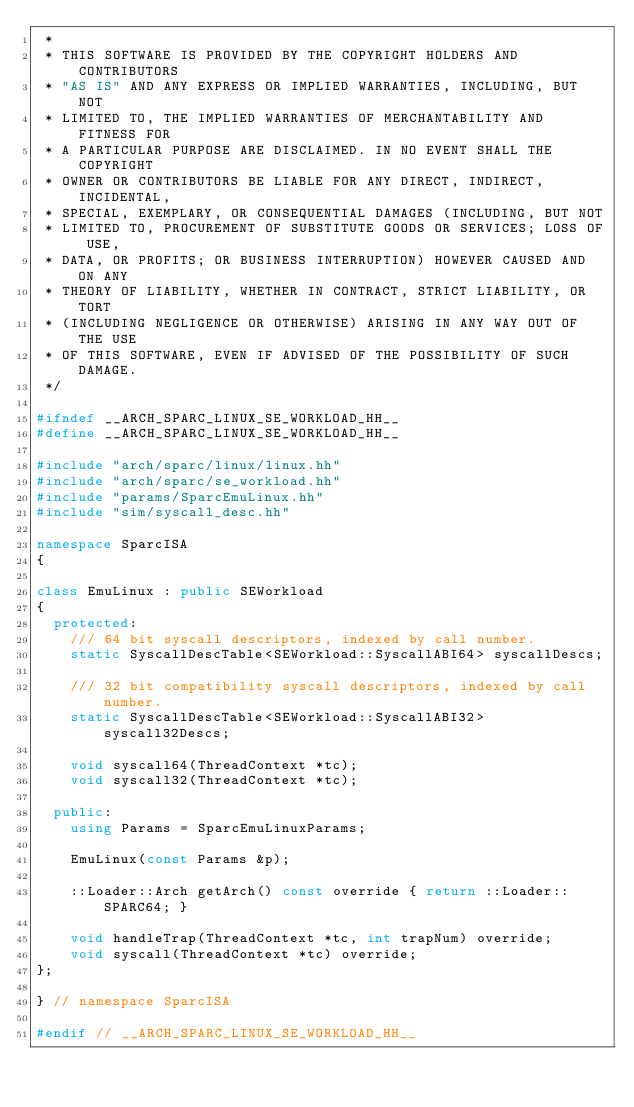<code> <loc_0><loc_0><loc_500><loc_500><_C++_> *
 * THIS SOFTWARE IS PROVIDED BY THE COPYRIGHT HOLDERS AND CONTRIBUTORS
 * "AS IS" AND ANY EXPRESS OR IMPLIED WARRANTIES, INCLUDING, BUT NOT
 * LIMITED TO, THE IMPLIED WARRANTIES OF MERCHANTABILITY AND FITNESS FOR
 * A PARTICULAR PURPOSE ARE DISCLAIMED. IN NO EVENT SHALL THE COPYRIGHT
 * OWNER OR CONTRIBUTORS BE LIABLE FOR ANY DIRECT, INDIRECT, INCIDENTAL,
 * SPECIAL, EXEMPLARY, OR CONSEQUENTIAL DAMAGES (INCLUDING, BUT NOT
 * LIMITED TO, PROCUREMENT OF SUBSTITUTE GOODS OR SERVICES; LOSS OF USE,
 * DATA, OR PROFITS; OR BUSINESS INTERRUPTION) HOWEVER CAUSED AND ON ANY
 * THEORY OF LIABILITY, WHETHER IN CONTRACT, STRICT LIABILITY, OR TORT
 * (INCLUDING NEGLIGENCE OR OTHERWISE) ARISING IN ANY WAY OUT OF THE USE
 * OF THIS SOFTWARE, EVEN IF ADVISED OF THE POSSIBILITY OF SUCH DAMAGE.
 */

#ifndef __ARCH_SPARC_LINUX_SE_WORKLOAD_HH__
#define __ARCH_SPARC_LINUX_SE_WORKLOAD_HH__

#include "arch/sparc/linux/linux.hh"
#include "arch/sparc/se_workload.hh"
#include "params/SparcEmuLinux.hh"
#include "sim/syscall_desc.hh"

namespace SparcISA
{

class EmuLinux : public SEWorkload
{
  protected:
    /// 64 bit syscall descriptors, indexed by call number.
    static SyscallDescTable<SEWorkload::SyscallABI64> syscallDescs;

    /// 32 bit compatibility syscall descriptors, indexed by call number.
    static SyscallDescTable<SEWorkload::SyscallABI32> syscall32Descs;

    void syscall64(ThreadContext *tc);
    void syscall32(ThreadContext *tc);

  public:
    using Params = SparcEmuLinuxParams;

    EmuLinux(const Params &p);

    ::Loader::Arch getArch() const override { return ::Loader::SPARC64; }

    void handleTrap(ThreadContext *tc, int trapNum) override;
    void syscall(ThreadContext *tc) override;
};

} // namespace SparcISA

#endif // __ARCH_SPARC_LINUX_SE_WORKLOAD_HH__
</code> 